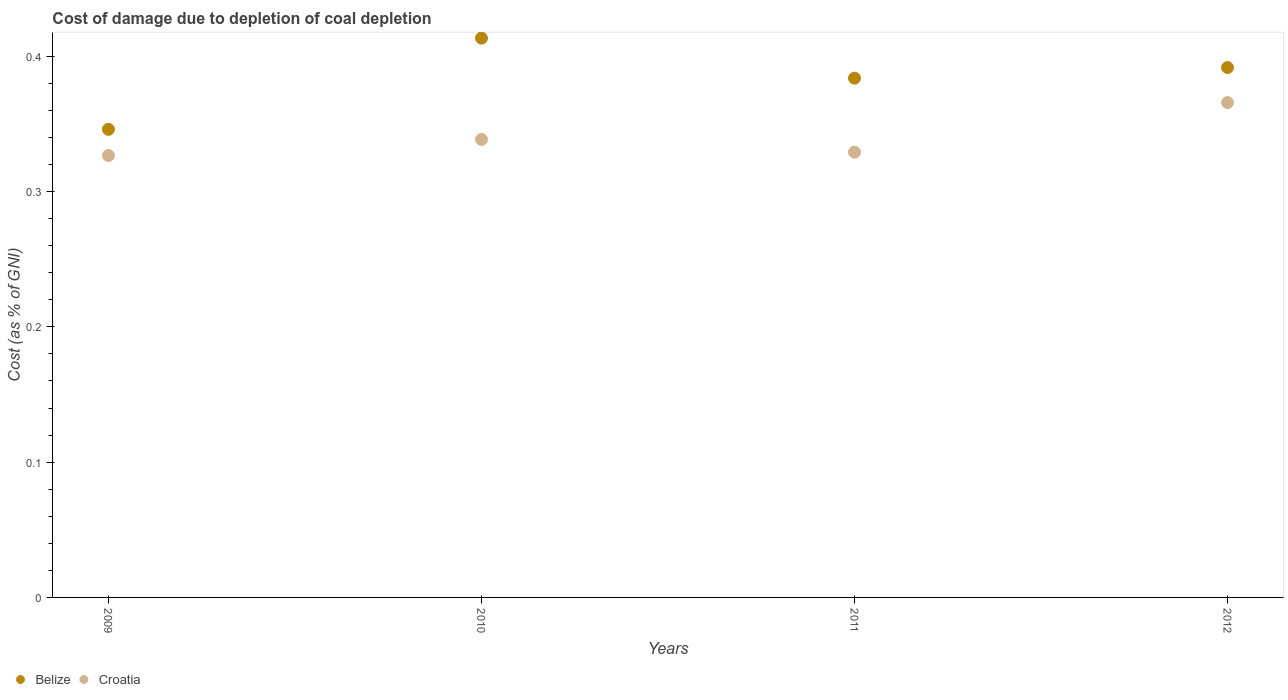How many different coloured dotlines are there?
Give a very brief answer. 2. Is the number of dotlines equal to the number of legend labels?
Offer a very short reply. Yes. What is the cost of damage caused due to coal depletion in Croatia in 2009?
Give a very brief answer. 0.33. Across all years, what is the maximum cost of damage caused due to coal depletion in Belize?
Make the answer very short. 0.41. Across all years, what is the minimum cost of damage caused due to coal depletion in Belize?
Your answer should be very brief. 0.35. In which year was the cost of damage caused due to coal depletion in Belize maximum?
Your response must be concise. 2010. In which year was the cost of damage caused due to coal depletion in Belize minimum?
Your response must be concise. 2009. What is the total cost of damage caused due to coal depletion in Belize in the graph?
Keep it short and to the point. 1.54. What is the difference between the cost of damage caused due to coal depletion in Belize in 2010 and that in 2012?
Provide a succinct answer. 0.02. What is the difference between the cost of damage caused due to coal depletion in Croatia in 2011 and the cost of damage caused due to coal depletion in Belize in 2009?
Your response must be concise. -0.02. What is the average cost of damage caused due to coal depletion in Croatia per year?
Your response must be concise. 0.34. In the year 2010, what is the difference between the cost of damage caused due to coal depletion in Belize and cost of damage caused due to coal depletion in Croatia?
Your answer should be compact. 0.07. What is the ratio of the cost of damage caused due to coal depletion in Croatia in 2010 to that in 2012?
Give a very brief answer. 0.93. Is the cost of damage caused due to coal depletion in Croatia in 2009 less than that in 2012?
Offer a terse response. Yes. Is the difference between the cost of damage caused due to coal depletion in Belize in 2009 and 2010 greater than the difference between the cost of damage caused due to coal depletion in Croatia in 2009 and 2010?
Make the answer very short. No. What is the difference between the highest and the second highest cost of damage caused due to coal depletion in Croatia?
Provide a succinct answer. 0.03. What is the difference between the highest and the lowest cost of damage caused due to coal depletion in Belize?
Your answer should be very brief. 0.07. Is the sum of the cost of damage caused due to coal depletion in Belize in 2010 and 2012 greater than the maximum cost of damage caused due to coal depletion in Croatia across all years?
Offer a very short reply. Yes. Does the cost of damage caused due to coal depletion in Croatia monotonically increase over the years?
Offer a very short reply. No. How many dotlines are there?
Your response must be concise. 2. How many years are there in the graph?
Your response must be concise. 4. Does the graph contain grids?
Provide a short and direct response. No. How are the legend labels stacked?
Give a very brief answer. Horizontal. What is the title of the graph?
Make the answer very short. Cost of damage due to depletion of coal depletion. Does "Caribbean small states" appear as one of the legend labels in the graph?
Give a very brief answer. No. What is the label or title of the X-axis?
Offer a very short reply. Years. What is the label or title of the Y-axis?
Your response must be concise. Cost (as % of GNI). What is the Cost (as % of GNI) in Belize in 2009?
Offer a very short reply. 0.35. What is the Cost (as % of GNI) of Croatia in 2009?
Keep it short and to the point. 0.33. What is the Cost (as % of GNI) of Belize in 2010?
Provide a succinct answer. 0.41. What is the Cost (as % of GNI) of Croatia in 2010?
Your answer should be very brief. 0.34. What is the Cost (as % of GNI) of Belize in 2011?
Offer a very short reply. 0.38. What is the Cost (as % of GNI) of Croatia in 2011?
Offer a terse response. 0.33. What is the Cost (as % of GNI) of Belize in 2012?
Give a very brief answer. 0.39. What is the Cost (as % of GNI) of Croatia in 2012?
Your response must be concise. 0.37. Across all years, what is the maximum Cost (as % of GNI) in Belize?
Make the answer very short. 0.41. Across all years, what is the maximum Cost (as % of GNI) of Croatia?
Offer a terse response. 0.37. Across all years, what is the minimum Cost (as % of GNI) in Belize?
Your response must be concise. 0.35. Across all years, what is the minimum Cost (as % of GNI) in Croatia?
Make the answer very short. 0.33. What is the total Cost (as % of GNI) in Belize in the graph?
Make the answer very short. 1.53. What is the total Cost (as % of GNI) in Croatia in the graph?
Give a very brief answer. 1.36. What is the difference between the Cost (as % of GNI) of Belize in 2009 and that in 2010?
Provide a short and direct response. -0.07. What is the difference between the Cost (as % of GNI) of Croatia in 2009 and that in 2010?
Make the answer very short. -0.01. What is the difference between the Cost (as % of GNI) of Belize in 2009 and that in 2011?
Your answer should be very brief. -0.04. What is the difference between the Cost (as % of GNI) in Croatia in 2009 and that in 2011?
Ensure brevity in your answer.  -0. What is the difference between the Cost (as % of GNI) in Belize in 2009 and that in 2012?
Your answer should be compact. -0.05. What is the difference between the Cost (as % of GNI) in Croatia in 2009 and that in 2012?
Provide a short and direct response. -0.04. What is the difference between the Cost (as % of GNI) in Belize in 2010 and that in 2011?
Keep it short and to the point. 0.03. What is the difference between the Cost (as % of GNI) of Croatia in 2010 and that in 2011?
Offer a very short reply. 0.01. What is the difference between the Cost (as % of GNI) of Belize in 2010 and that in 2012?
Your answer should be very brief. 0.02. What is the difference between the Cost (as % of GNI) in Croatia in 2010 and that in 2012?
Your answer should be very brief. -0.03. What is the difference between the Cost (as % of GNI) of Belize in 2011 and that in 2012?
Make the answer very short. -0.01. What is the difference between the Cost (as % of GNI) of Croatia in 2011 and that in 2012?
Offer a very short reply. -0.04. What is the difference between the Cost (as % of GNI) of Belize in 2009 and the Cost (as % of GNI) of Croatia in 2010?
Offer a very short reply. 0.01. What is the difference between the Cost (as % of GNI) of Belize in 2009 and the Cost (as % of GNI) of Croatia in 2011?
Offer a terse response. 0.02. What is the difference between the Cost (as % of GNI) in Belize in 2009 and the Cost (as % of GNI) in Croatia in 2012?
Your answer should be compact. -0.02. What is the difference between the Cost (as % of GNI) in Belize in 2010 and the Cost (as % of GNI) in Croatia in 2011?
Provide a succinct answer. 0.08. What is the difference between the Cost (as % of GNI) of Belize in 2010 and the Cost (as % of GNI) of Croatia in 2012?
Your answer should be compact. 0.05. What is the difference between the Cost (as % of GNI) of Belize in 2011 and the Cost (as % of GNI) of Croatia in 2012?
Provide a short and direct response. 0.02. What is the average Cost (as % of GNI) in Belize per year?
Keep it short and to the point. 0.38. What is the average Cost (as % of GNI) of Croatia per year?
Keep it short and to the point. 0.34. In the year 2009, what is the difference between the Cost (as % of GNI) of Belize and Cost (as % of GNI) of Croatia?
Offer a very short reply. 0.02. In the year 2010, what is the difference between the Cost (as % of GNI) of Belize and Cost (as % of GNI) of Croatia?
Offer a terse response. 0.07. In the year 2011, what is the difference between the Cost (as % of GNI) of Belize and Cost (as % of GNI) of Croatia?
Your answer should be very brief. 0.05. In the year 2012, what is the difference between the Cost (as % of GNI) in Belize and Cost (as % of GNI) in Croatia?
Your answer should be very brief. 0.03. What is the ratio of the Cost (as % of GNI) in Belize in 2009 to that in 2010?
Offer a very short reply. 0.84. What is the ratio of the Cost (as % of GNI) in Croatia in 2009 to that in 2010?
Your answer should be very brief. 0.96. What is the ratio of the Cost (as % of GNI) in Belize in 2009 to that in 2011?
Offer a very short reply. 0.9. What is the ratio of the Cost (as % of GNI) of Belize in 2009 to that in 2012?
Ensure brevity in your answer.  0.88. What is the ratio of the Cost (as % of GNI) in Croatia in 2009 to that in 2012?
Your response must be concise. 0.89. What is the ratio of the Cost (as % of GNI) of Belize in 2010 to that in 2011?
Offer a terse response. 1.08. What is the ratio of the Cost (as % of GNI) of Croatia in 2010 to that in 2011?
Provide a succinct answer. 1.03. What is the ratio of the Cost (as % of GNI) of Belize in 2010 to that in 2012?
Make the answer very short. 1.06. What is the ratio of the Cost (as % of GNI) in Croatia in 2010 to that in 2012?
Provide a short and direct response. 0.93. What is the ratio of the Cost (as % of GNI) of Belize in 2011 to that in 2012?
Offer a terse response. 0.98. What is the ratio of the Cost (as % of GNI) in Croatia in 2011 to that in 2012?
Make the answer very short. 0.9. What is the difference between the highest and the second highest Cost (as % of GNI) of Belize?
Provide a succinct answer. 0.02. What is the difference between the highest and the second highest Cost (as % of GNI) in Croatia?
Offer a very short reply. 0.03. What is the difference between the highest and the lowest Cost (as % of GNI) of Belize?
Offer a terse response. 0.07. What is the difference between the highest and the lowest Cost (as % of GNI) of Croatia?
Provide a succinct answer. 0.04. 